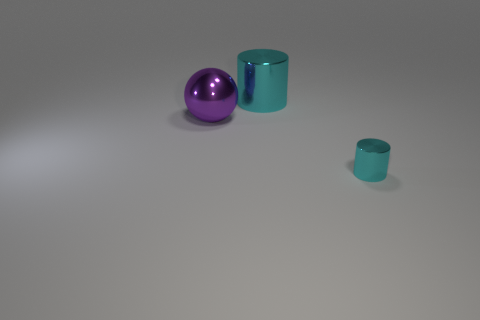What sort of material do these objects appear to be made of? The objects in the image have a smooth, reflective surface that suggests they could be made of a polished metal or a type of plastic with a glossy finish. The way the light reflects off their surfaces gives a sense of solidity and smooth texture. 